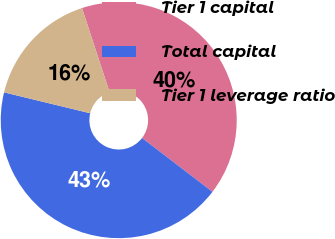<chart> <loc_0><loc_0><loc_500><loc_500><pie_chart><fcel>Tier 1 capital<fcel>Total capital<fcel>Tier 1 leverage ratio<nl><fcel>40.43%<fcel>43.39%<fcel>16.17%<nl></chart> 